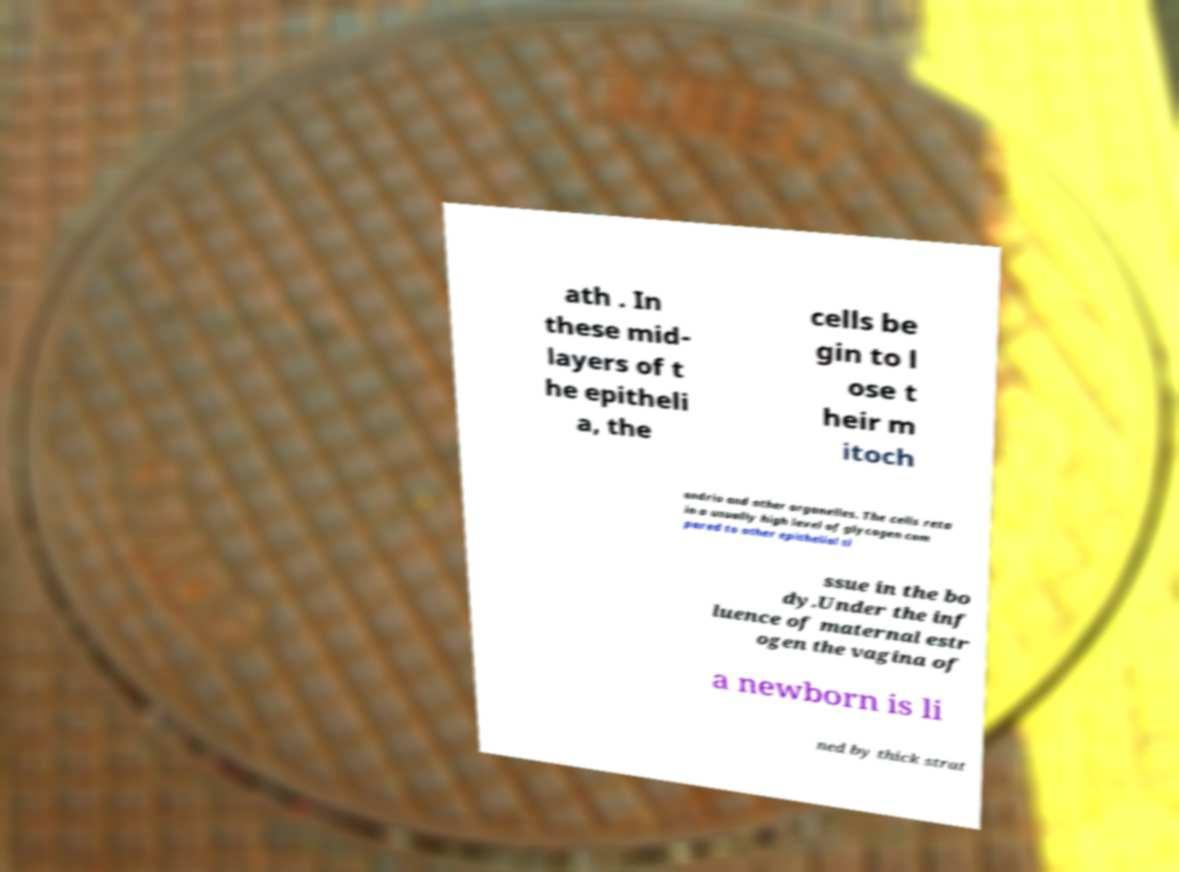Please read and relay the text visible in this image. What does it say? ath . In these mid- layers of t he epitheli a, the cells be gin to l ose t heir m itoch ondria and other organelles. The cells reta in a usually high level of glycogen com pared to other epithelial ti ssue in the bo dy.Under the inf luence of maternal estr ogen the vagina of a newborn is li ned by thick strat 